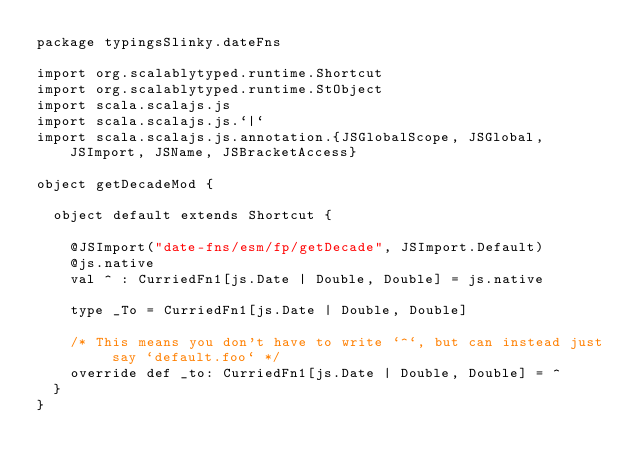Convert code to text. <code><loc_0><loc_0><loc_500><loc_500><_Scala_>package typingsSlinky.dateFns

import org.scalablytyped.runtime.Shortcut
import org.scalablytyped.runtime.StObject
import scala.scalajs.js
import scala.scalajs.js.`|`
import scala.scalajs.js.annotation.{JSGlobalScope, JSGlobal, JSImport, JSName, JSBracketAccess}

object getDecadeMod {
  
  object default extends Shortcut {
    
    @JSImport("date-fns/esm/fp/getDecade", JSImport.Default)
    @js.native
    val ^ : CurriedFn1[js.Date | Double, Double] = js.native
    
    type _To = CurriedFn1[js.Date | Double, Double]
    
    /* This means you don't have to write `^`, but can instead just say `default.foo` */
    override def _to: CurriedFn1[js.Date | Double, Double] = ^
  }
}
</code> 